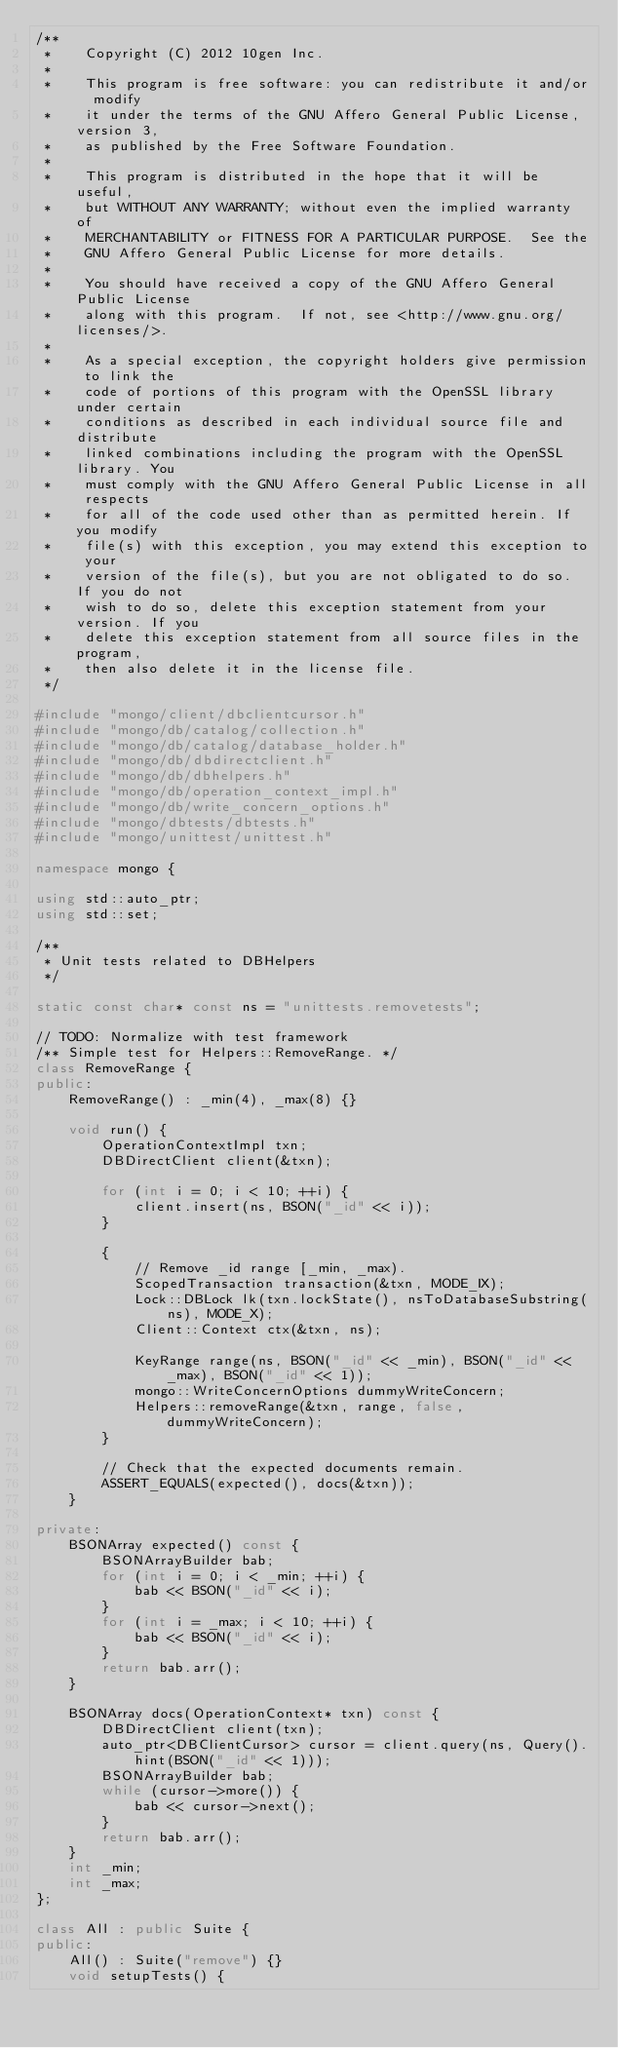<code> <loc_0><loc_0><loc_500><loc_500><_C++_>/**
 *    Copyright (C) 2012 10gen Inc.
 *
 *    This program is free software: you can redistribute it and/or  modify
 *    it under the terms of the GNU Affero General Public License, version 3,
 *    as published by the Free Software Foundation.
 *
 *    This program is distributed in the hope that it will be useful,
 *    but WITHOUT ANY WARRANTY; without even the implied warranty of
 *    MERCHANTABILITY or FITNESS FOR A PARTICULAR PURPOSE.  See the
 *    GNU Affero General Public License for more details.
 *
 *    You should have received a copy of the GNU Affero General Public License
 *    along with this program.  If not, see <http://www.gnu.org/licenses/>.
 *
 *    As a special exception, the copyright holders give permission to link the
 *    code of portions of this program with the OpenSSL library under certain
 *    conditions as described in each individual source file and distribute
 *    linked combinations including the program with the OpenSSL library. You
 *    must comply with the GNU Affero General Public License in all respects
 *    for all of the code used other than as permitted herein. If you modify
 *    file(s) with this exception, you may extend this exception to your
 *    version of the file(s), but you are not obligated to do so. If you do not
 *    wish to do so, delete this exception statement from your version. If you
 *    delete this exception statement from all source files in the program,
 *    then also delete it in the license file.
 */

#include "mongo/client/dbclientcursor.h"
#include "mongo/db/catalog/collection.h"
#include "mongo/db/catalog/database_holder.h"
#include "mongo/db/dbdirectclient.h"
#include "mongo/db/dbhelpers.h"
#include "mongo/db/operation_context_impl.h"
#include "mongo/db/write_concern_options.h"
#include "mongo/dbtests/dbtests.h"
#include "mongo/unittest/unittest.h"

namespace mongo {

using std::auto_ptr;
using std::set;

/**
 * Unit tests related to DBHelpers
 */

static const char* const ns = "unittests.removetests";

// TODO: Normalize with test framework
/** Simple test for Helpers::RemoveRange. */
class RemoveRange {
public:
    RemoveRange() : _min(4), _max(8) {}

    void run() {
        OperationContextImpl txn;
        DBDirectClient client(&txn);

        for (int i = 0; i < 10; ++i) {
            client.insert(ns, BSON("_id" << i));
        }

        {
            // Remove _id range [_min, _max).
            ScopedTransaction transaction(&txn, MODE_IX);
            Lock::DBLock lk(txn.lockState(), nsToDatabaseSubstring(ns), MODE_X);
            Client::Context ctx(&txn, ns);

            KeyRange range(ns, BSON("_id" << _min), BSON("_id" << _max), BSON("_id" << 1));
            mongo::WriteConcernOptions dummyWriteConcern;
            Helpers::removeRange(&txn, range, false, dummyWriteConcern);
        }

        // Check that the expected documents remain.
        ASSERT_EQUALS(expected(), docs(&txn));
    }

private:
    BSONArray expected() const {
        BSONArrayBuilder bab;
        for (int i = 0; i < _min; ++i) {
            bab << BSON("_id" << i);
        }
        for (int i = _max; i < 10; ++i) {
            bab << BSON("_id" << i);
        }
        return bab.arr();
    }

    BSONArray docs(OperationContext* txn) const {
        DBDirectClient client(txn);
        auto_ptr<DBClientCursor> cursor = client.query(ns, Query().hint(BSON("_id" << 1)));
        BSONArrayBuilder bab;
        while (cursor->more()) {
            bab << cursor->next();
        }
        return bab.arr();
    }
    int _min;
    int _max;
};

class All : public Suite {
public:
    All() : Suite("remove") {}
    void setupTests() {</code> 